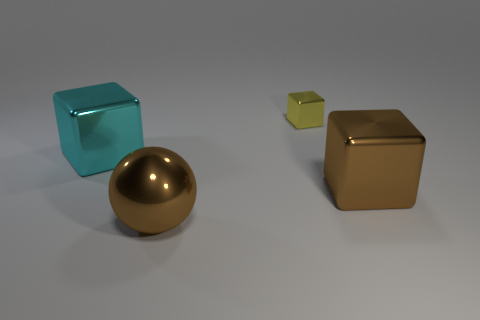Can you describe the textures of the objects in the image? The objects in the image have various textures. The large ball has a smooth, reflective golden surface, giving it a glossy look. The large cyan cube appears smooth with a slight metallic sheen. The small greenish-yellow cube exhibits a matte finish, and the two large brown metallic cubes have a brushed, slightly reflective texture. 